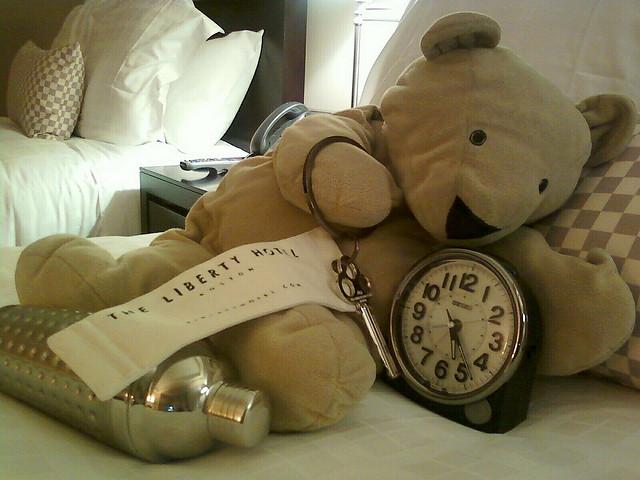Is this a bedroom?
Answer briefly. Yes. Is this an advertisement for a clock?
Short answer required. No. Which object is not a toy?
Concise answer only. Clock. What is around the teddy bear's hand?
Answer briefly. Key. 